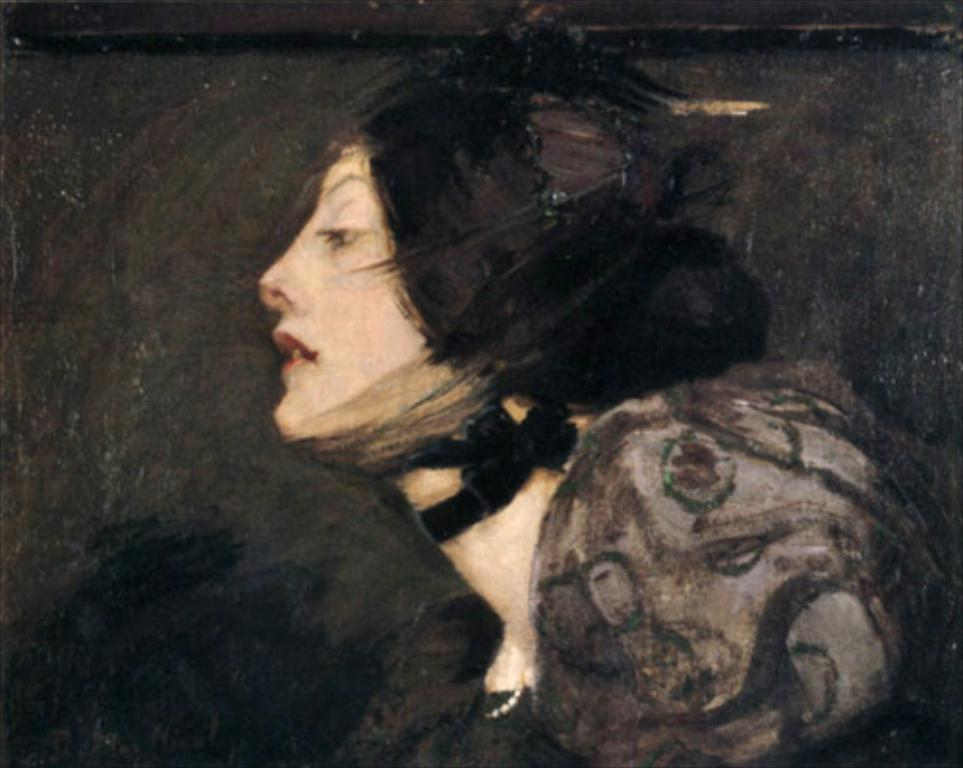What type of artwork is depicted in the image? The image is a painting. Who or what is the main subject of the painting? There is a woman in the painting. What is the woman wearing in the painting? The woman is wearing a black dress. What color is the background of the painting? The background of the painting is black in color. How much was the payment for the sack in the painting? There is no payment or sack present in the painting; it features a woman wearing a black dress against a black background. 